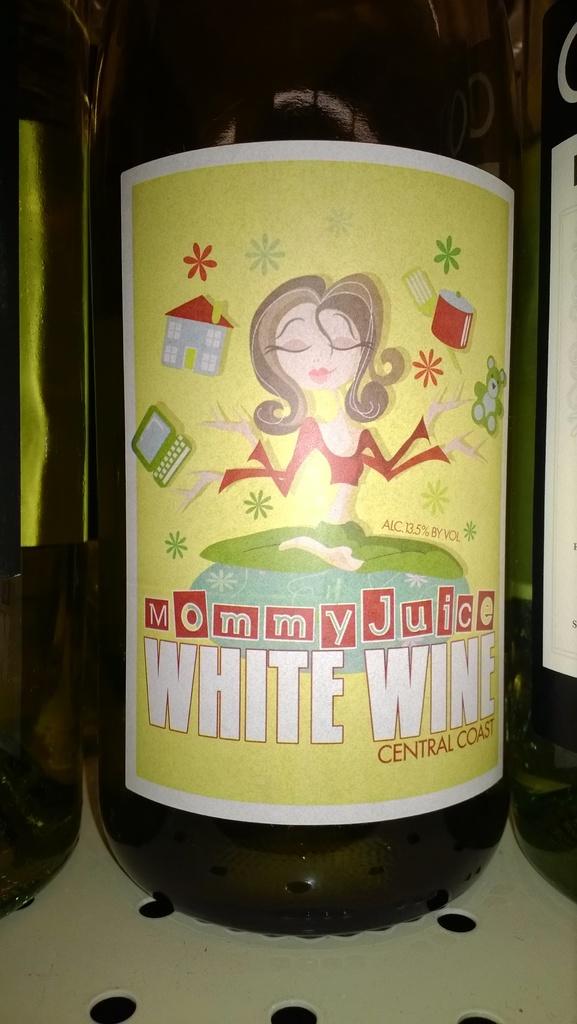What is the name of this wine?
Keep it short and to the point. Mommy juice. What type of wine is this?
Ensure brevity in your answer.  White. 